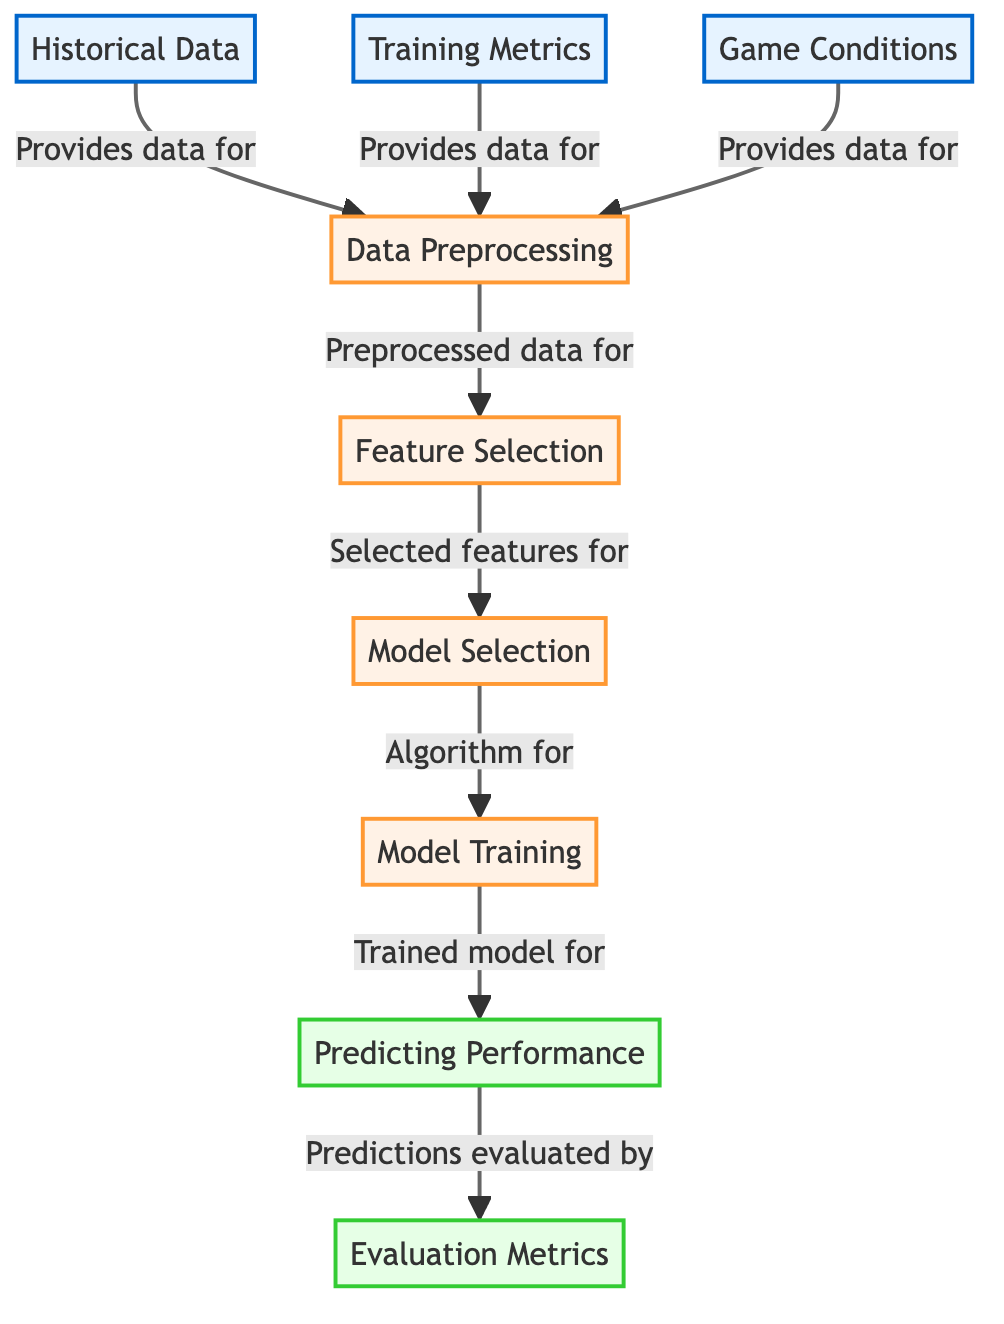What are the three main input data sources? The diagram indicates three main input data sources: Historical Data, Training Metrics, and Game Conditions. These are the starting points for the machine learning process.
Answer: Historical Data, Training Metrics, Game Conditions How many processes are involved in the diagram? The diagram shows five distinct processes: Data Preprocessing, Feature Selection, Model Selection, Model Training, and Predicting Performance. Therefore, the total number of processes is five.
Answer: Five Which process generates the predictions? The process responsible for generating the predictions is labeled "Predicting Performance." This is the final output stage of the machine learning workflow depicted in the diagram.
Answer: Predicting Performance What is the role of "Data Preprocessing"? "Data Preprocessing" serves as the critical step that prepares the input data for subsequent processes, specifically for "Feature Selection." This step ensures that the data is clean and usable for analysis.
Answer: Prepares data How does "Model Selection" relate to "Feature Selection"? "Model Selection" is directly dependent on the output from "Feature Selection," as it takes the selected features from that process to determine which algorithm to apply during model training. Thus, one can say that Model Selection follows Feature Selection.
Answer: Selected features for What type of metrics are evaluated in the diagram? The evaluation metrics referred to in the diagram are labeled as "Evaluation Metrics." This indicates that they assess the accuracy and performance of the predictions made by the model.
Answer: Evaluation Metrics How does "Model Training" connect to "Predicting Performance"? "Model Training" involves the creation of a trained model, which then directly informs the "Predicting Performance" step where actual predictions of player performance are made using that trained model.
Answer: Trained model for Which process follows "Data Preprocessing"? Following "Data Preprocessing," the next step in the workflow is "Feature Selection." This sequence is crucial as it builds on the cleaned data to determine which features are most relevant for the modeling process.
Answer: Feature Selection What comes after "Model Training"? The process that comes after "Model Training" is "Predicting Performance." This indicates that once the model is trained, it is used to make actual predictions about player performance.
Answer: Predicting Performance 